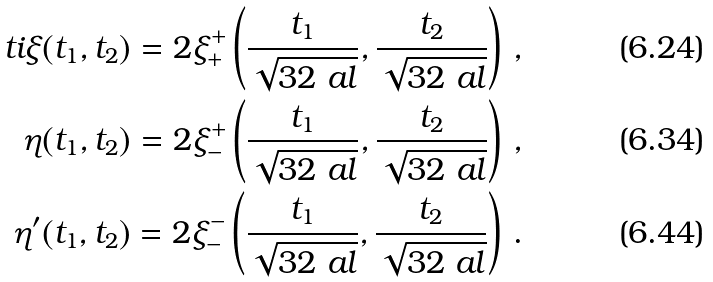Convert formula to latex. <formula><loc_0><loc_0><loc_500><loc_500>\ t i \xi ( t _ { 1 } , t _ { 2 } ) = 2 \xi _ { + } ^ { + } \left ( \frac { t _ { 1 } } { \sqrt { 3 2 \ a l } } , \frac { t _ { 2 } } { \sqrt { 3 2 \ a l } } \right ) \, , \\ \eta ( t _ { 1 } , t _ { 2 } ) = 2 \xi _ { - } ^ { + } \left ( \frac { t _ { 1 } } { \sqrt { 3 2 \ a l } } , \frac { t _ { 2 } } { \sqrt { 3 2 \ a l } } \right ) \, , \\ \eta ^ { \prime } ( t _ { 1 } , t _ { 2 } ) = 2 \xi _ { - } ^ { - } \left ( \frac { t _ { 1 } } { \sqrt { 3 2 \ a l } } , \frac { t _ { 2 } } { \sqrt { 3 2 \ a l } } \right ) \, .</formula> 